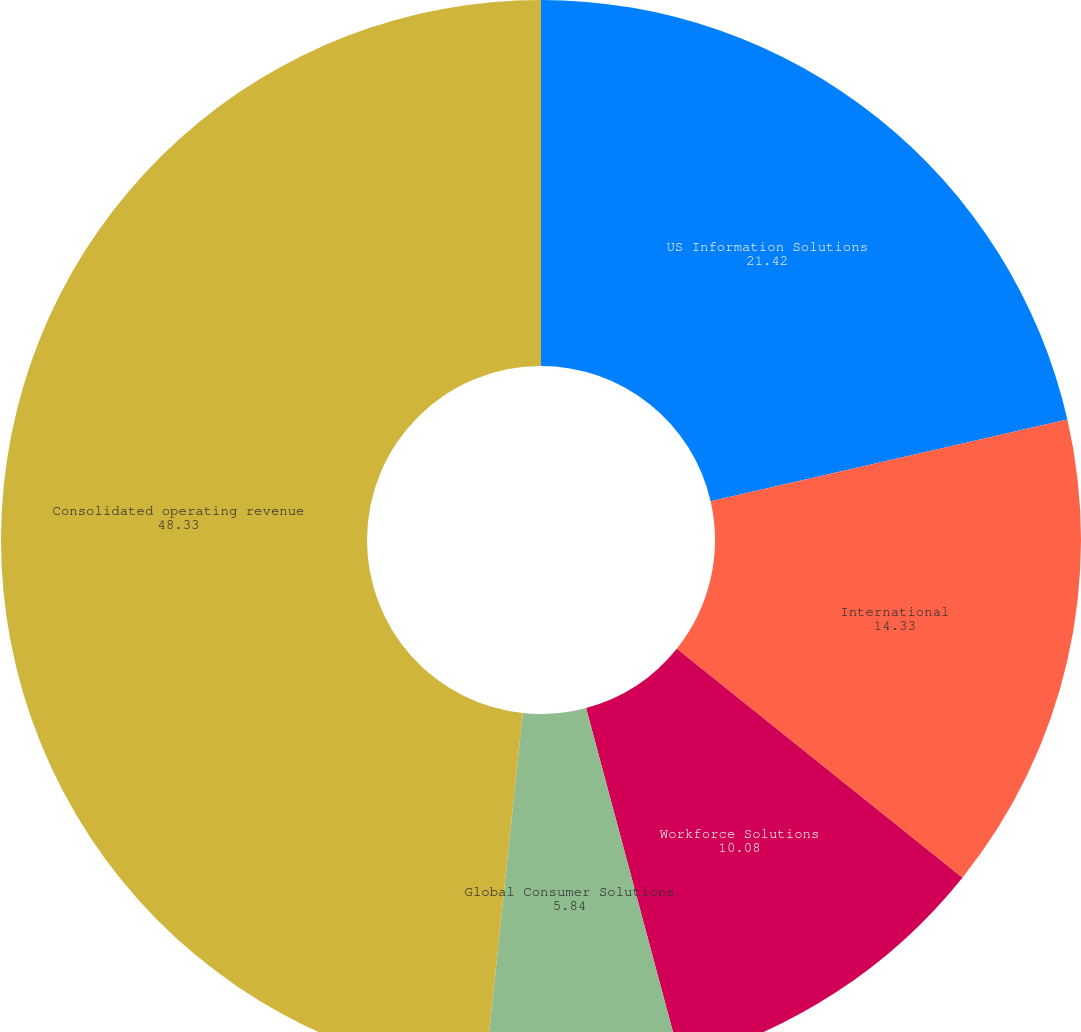Convert chart. <chart><loc_0><loc_0><loc_500><loc_500><pie_chart><fcel>US Information Solutions<fcel>International<fcel>Workforce Solutions<fcel>Global Consumer Solutions<fcel>Consolidated operating revenue<nl><fcel>21.42%<fcel>14.33%<fcel>10.08%<fcel>5.84%<fcel>48.33%<nl></chart> 